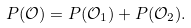<formula> <loc_0><loc_0><loc_500><loc_500>P ( \mathcal { O } ) = P ( \mathcal { O } _ { 1 } ) + P ( \mathcal { O } _ { 2 } ) .</formula> 